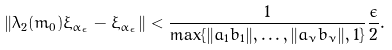Convert formula to latex. <formula><loc_0><loc_0><loc_500><loc_500>\| \lambda _ { 2 } ( m _ { 0 } ) \xi _ { \alpha _ { \epsilon } } - \xi _ { \alpha _ { \epsilon } } \| < \frac { 1 } { \max \{ \| a _ { 1 } b _ { 1 } \| , \dots , \| a _ { \nu } b _ { \nu } \| , 1 \} } \frac { \epsilon } { 2 } .</formula> 